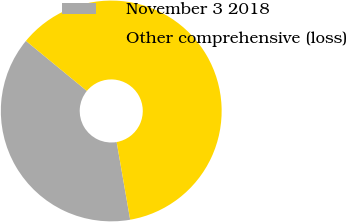Convert chart to OTSL. <chart><loc_0><loc_0><loc_500><loc_500><pie_chart><fcel>November 3 2018<fcel>Other comprehensive (loss)<nl><fcel>38.69%<fcel>61.31%<nl></chart> 